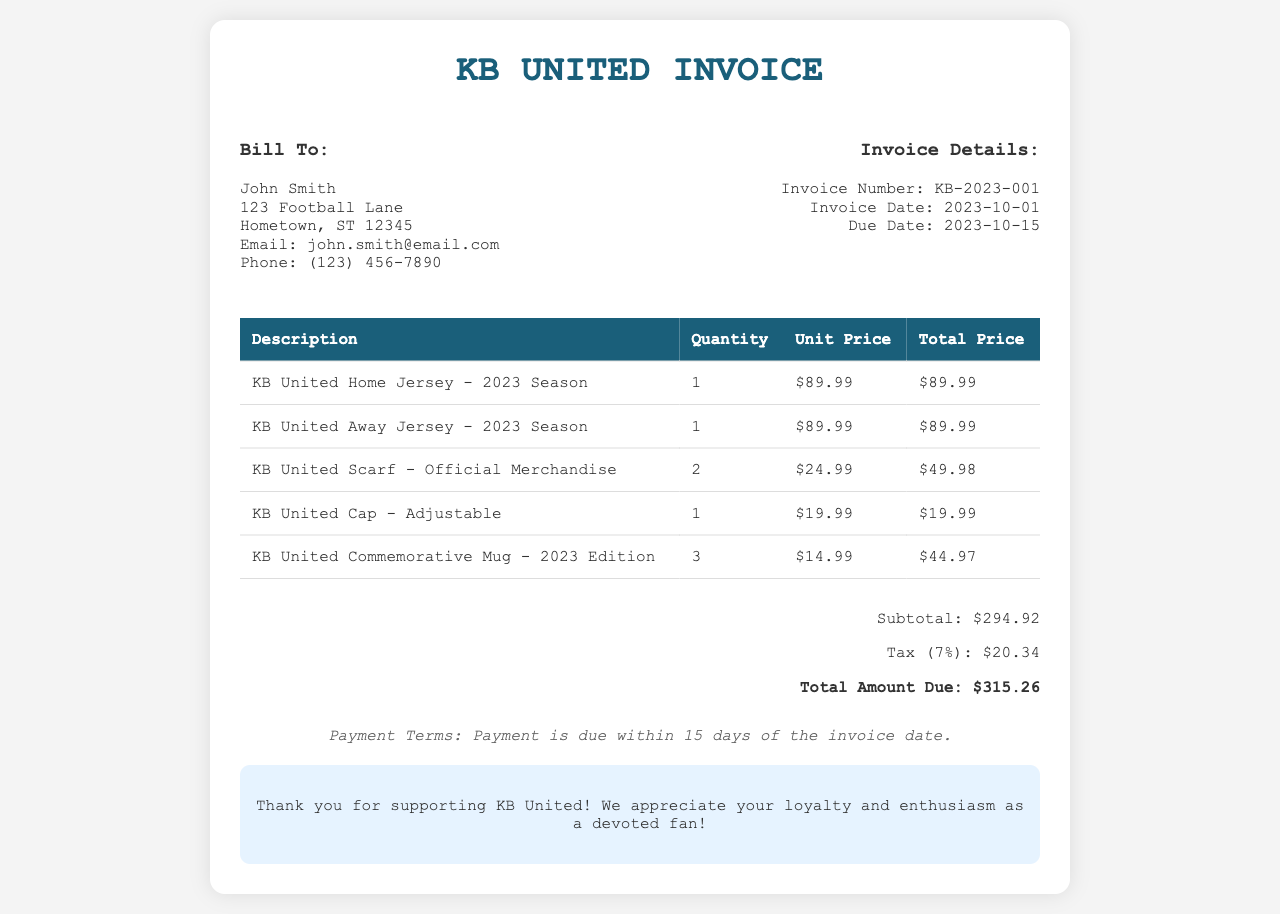What is the invoice number? The invoice number is located in the invoice details section, which is KB-2023-001.
Answer: KB-2023-001 Who is the bill to? The "Bill To" section provides information about the recipient, which is John Smith.
Answer: John Smith What is the total amount due? The total amount due is calculated and listed at the end of the invoice as $315.26.
Answer: $315.26 How many KB United Scarves did John Smith purchase? The quantity of KB United Scarves is found in the itemized list, which indicates 2 purchased.
Answer: 2 What is the due date for the invoice? The due date is provided in the invoice details, which is 2023-10-15.
Answer: 2023-10-15 What is the subtotal before tax? The subtotal is listed before the tax calculation, which is $294.92.
Answer: $294.92 How many commemorative mugs did John Smith order? The quantity of commemorative mugs can be found in the itemized table, where it states 3 mugs ordered.
Answer: 3 What percentage is the tax applied on the subtotal? The tax rate is specified as 7% in the invoice calculations.
Answer: 7% What is the payment term for the invoice? The invoice states that payment is due within 15 days of the invoice date.
Answer: 15 days 